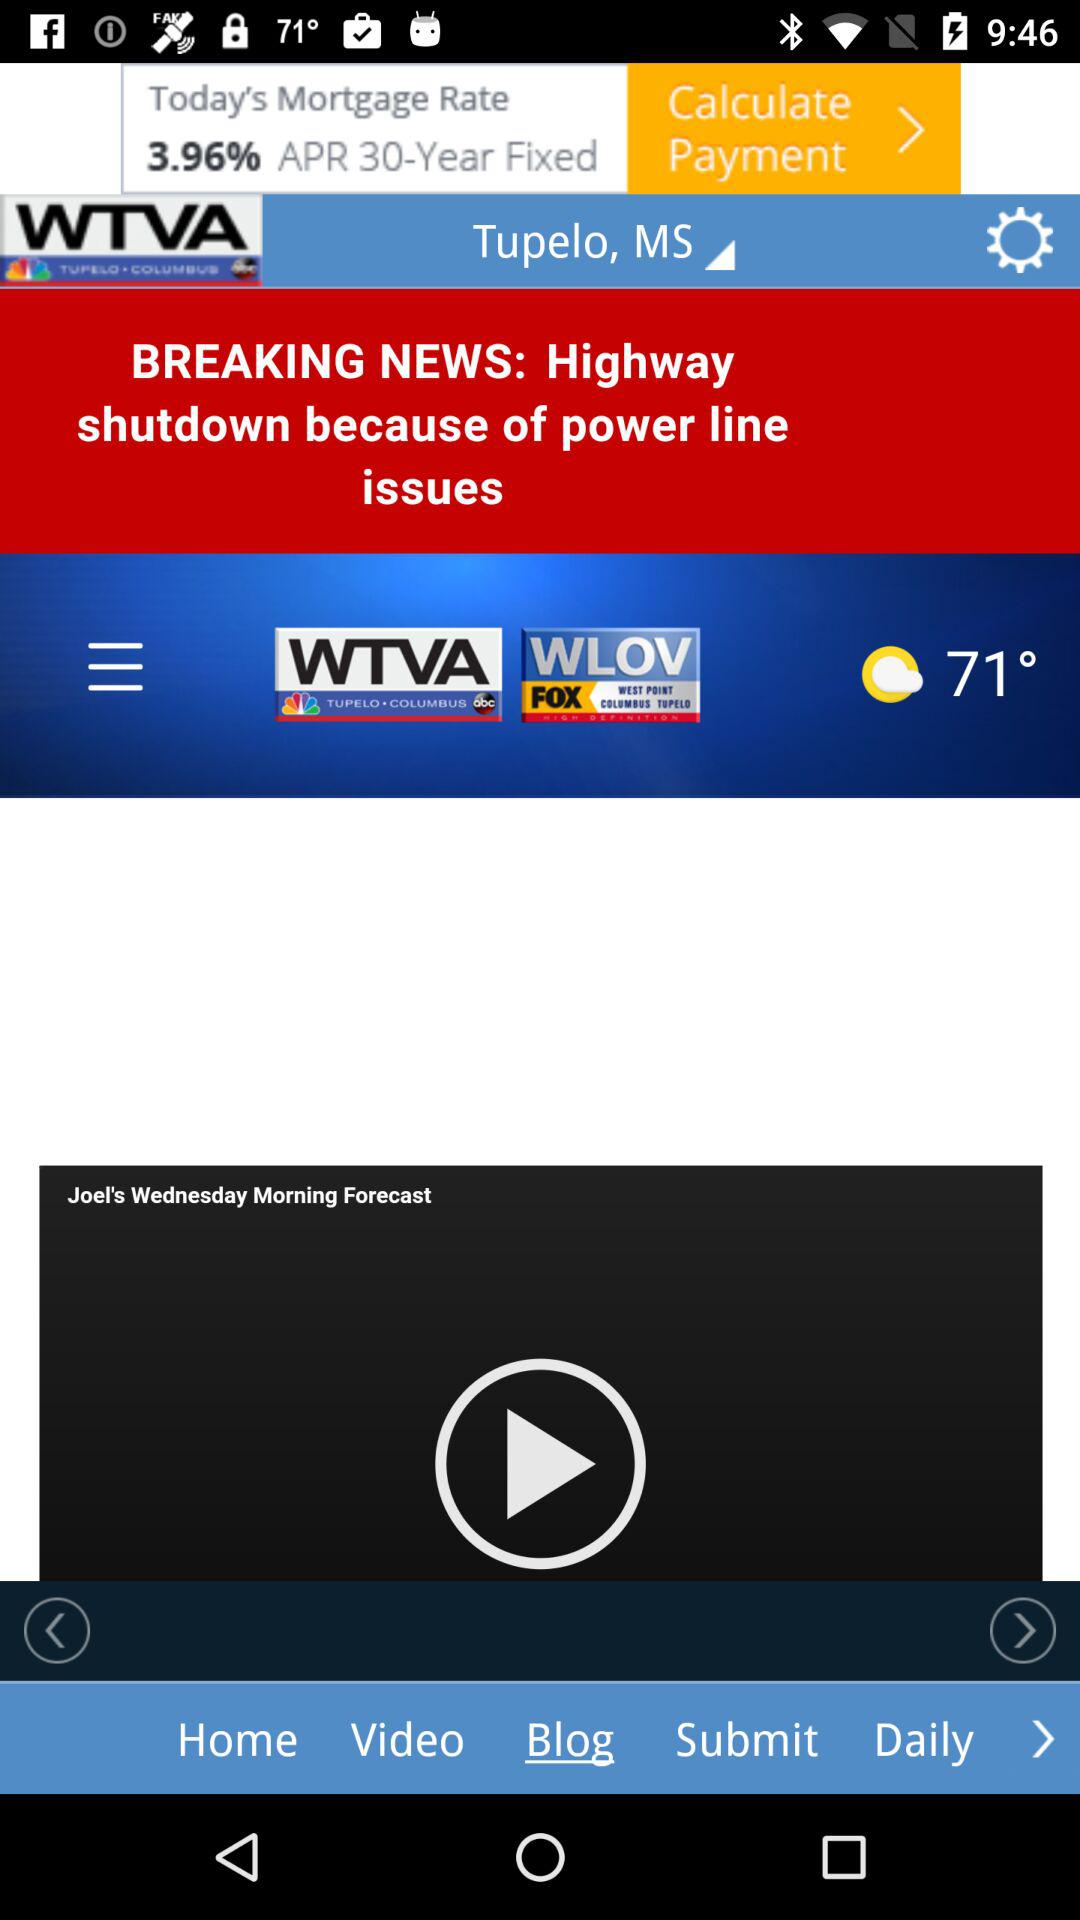How many degrees Fahrenheit is the temperature?
Answer the question using a single word or phrase. 71° 